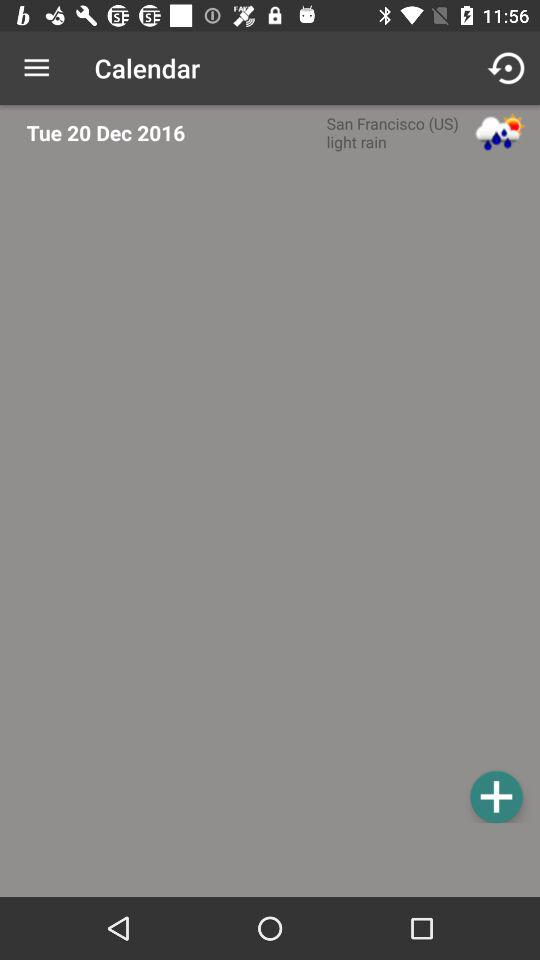What is the location in the calendar? The location is San Francisco (US). 